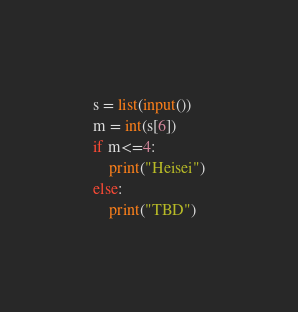Convert code to text. <code><loc_0><loc_0><loc_500><loc_500><_Python_>s = list(input())
m = int(s[6])
if m<=4:
    print("Heisei")
else:
    print("TBD")</code> 